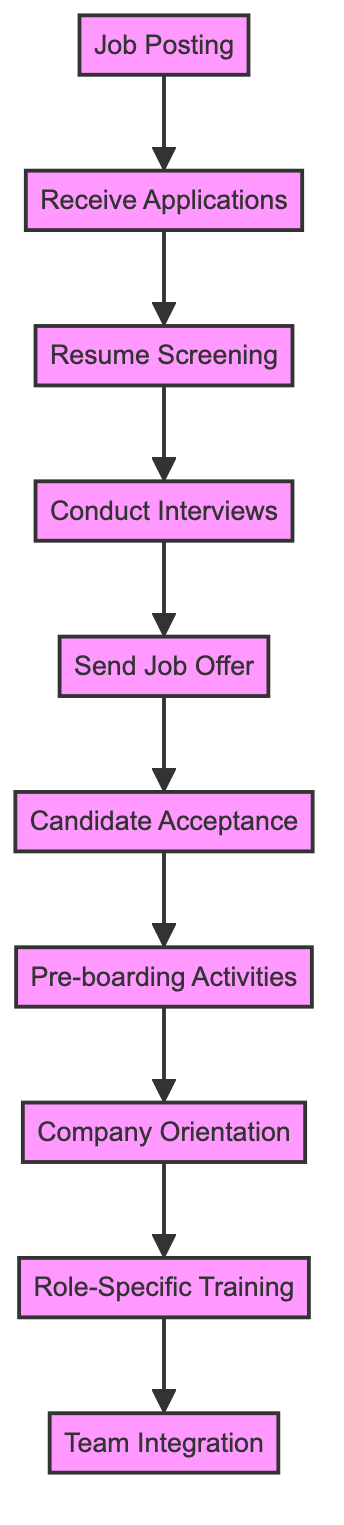What is the first step in the onboarding flow is? The first step in the onboarding flow is depicted in the node labeled "Job Posting." It is the initial stage from which the flowchart starts.
Answer: Job Posting How many nodes are there in the diagram? Counting all the distinct steps in the onboarding process, there are 10 nodes represented in the diagram. Each node corresponds to a particular phase of the onboarding flow.
Answer: 10 What is the last step in the onboarding process? The last step shown in the diagram is indicated by the node labeled "Team Integration," which represents the final stage of integrating a new employee into the team.
Answer: Team Integration Which step comes after "Resume Screening"? The flow of the diagram shows that the step after "Resume Screening," directly connected by an arrow, is "Conduct Interviews." This is the subsequent phase in processing candidate applications.
Answer: Conduct Interviews What are the first and last actions in the onboarding flow? The first action is "Job Posting," and the last action is "Team Integration." This describes the start and end points of the employee onboarding process as outlined in the diagram.
Answer: Job Posting and Team Integration What is the relationship between "Candidate Acceptance" and "Pre-boarding Activities"? The relationship is sequential. After "Candidate Acceptance," indicated by an arrow, the next step in the process is "Pre-boarding Activities." This implies that "Candidate Acceptance" must occur before proceeding to "Pre-boarding Activities."
Answer: Candidate Acceptance leads to Pre-boarding Activities How many edges are there in the graph? The number of edges corresponds to the connections between pairs of nodes, which in total equals 9 distinct edges in the diagram, showing the linear flow of the onboarding process.
Answer: 9 Which node is directly connected to "Company Orientation"? The node that comes directly after "Company Orientation" in the flow is "Role-Specific Training," indicating that "Company Orientation" leads directly to this training phase in the onboarding process.
Answer: Role-Specific Training What step follows "Send Job Offer"? Following the "Send Job Offer," the next step according to the arrows in the diagram is "Candidate Acceptance," indicating a direct continuation in the onboarding journey after an offer is sent.
Answer: Candidate Acceptance 